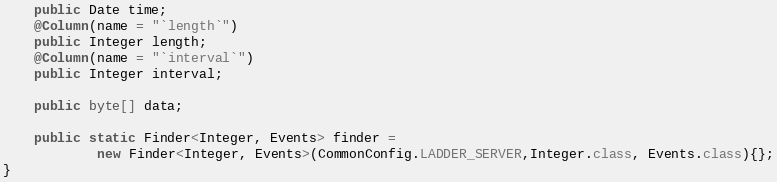<code> <loc_0><loc_0><loc_500><loc_500><_Java_>
    public Date time;
    @Column(name = "`length`")
    public Integer length;
    @Column(name = "`interval`")
    public Integer interval;

    public byte[] data;

    public static Finder<Integer, Events> finder =
            new Finder<Integer, Events>(CommonConfig.LADDER_SERVER,Integer.class, Events.class){};
}</code> 